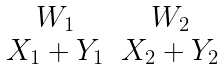Convert formula to latex. <formula><loc_0><loc_0><loc_500><loc_500>\begin{matrix} W _ { 1 } & W _ { 2 } \\ X _ { 1 } + Y _ { 1 } & X _ { 2 } + Y _ { 2 } \end{matrix}</formula> 